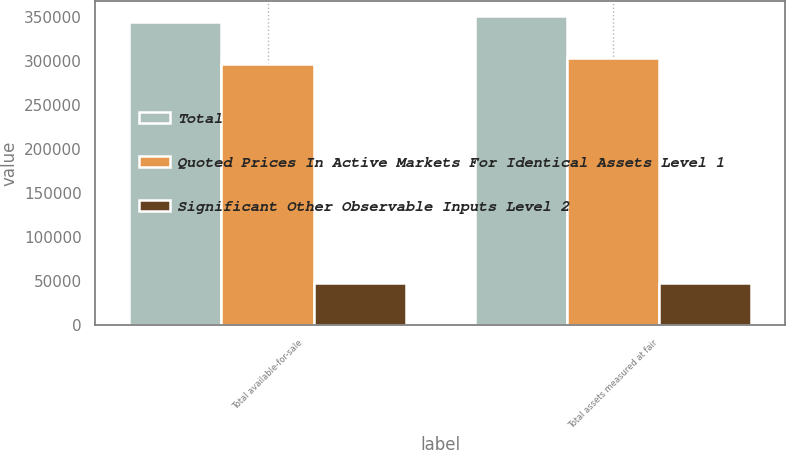Convert chart. <chart><loc_0><loc_0><loc_500><loc_500><stacked_bar_chart><ecel><fcel>Total available-for-sale<fcel>Total assets measured at fair<nl><fcel>Total<fcel>343981<fcel>350449<nl><fcel>Quoted Prices In Active Markets For Identical Assets Level 1<fcel>296671<fcel>303139<nl><fcel>Significant Other Observable Inputs Level 2<fcel>47310<fcel>47310<nl></chart> 